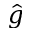<formula> <loc_0><loc_0><loc_500><loc_500>\hat { g }</formula> 